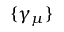<formula> <loc_0><loc_0><loc_500><loc_500>\{ \gamma _ { \mu } \}</formula> 